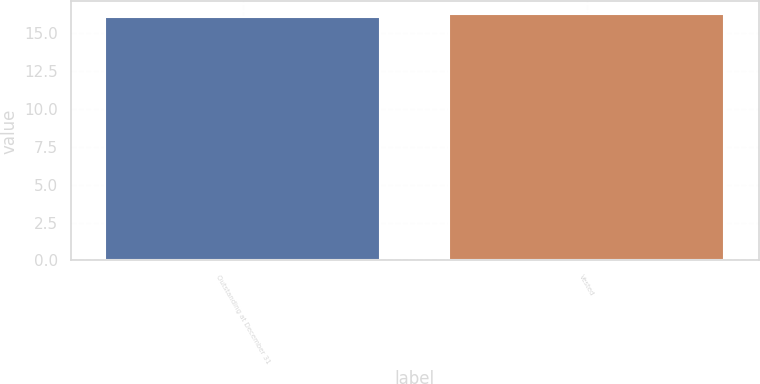<chart> <loc_0><loc_0><loc_500><loc_500><bar_chart><fcel>Outstanding at December 31<fcel>Vested<nl><fcel>16.04<fcel>16.28<nl></chart> 